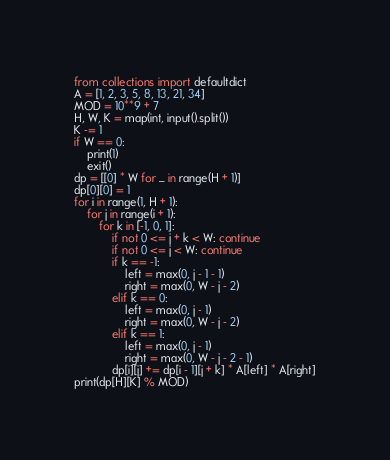Convert code to text. <code><loc_0><loc_0><loc_500><loc_500><_Python_>from collections import defaultdict
A = [1, 2, 3, 5, 8, 13, 21, 34]
MOD = 10**9 + 7
H, W, K = map(int, input().split())
K -= 1
if W == 0:
    print(1)
    exit()
dp = [[0] * W for _ in range(H + 1)]
dp[0][0] = 1
for i in range(1, H + 1):
    for j in range(i + 1):
        for k in [-1, 0, 1]:
            if not 0 <= j + k < W: continue
            if not 0 <= j < W: continue
            if k == -1:
                left = max(0, j - 1 - 1)
                right = max(0, W - j - 2)
            elif k == 0:
                left = max(0, j - 1)
                right = max(0, W - j - 2)
            elif k == 1:
                left = max(0, j - 1)
                right = max(0, W - j - 2 - 1)
            dp[i][j] += dp[i - 1][j + k] * A[left] * A[right]
print(dp[H][K] % MOD)</code> 